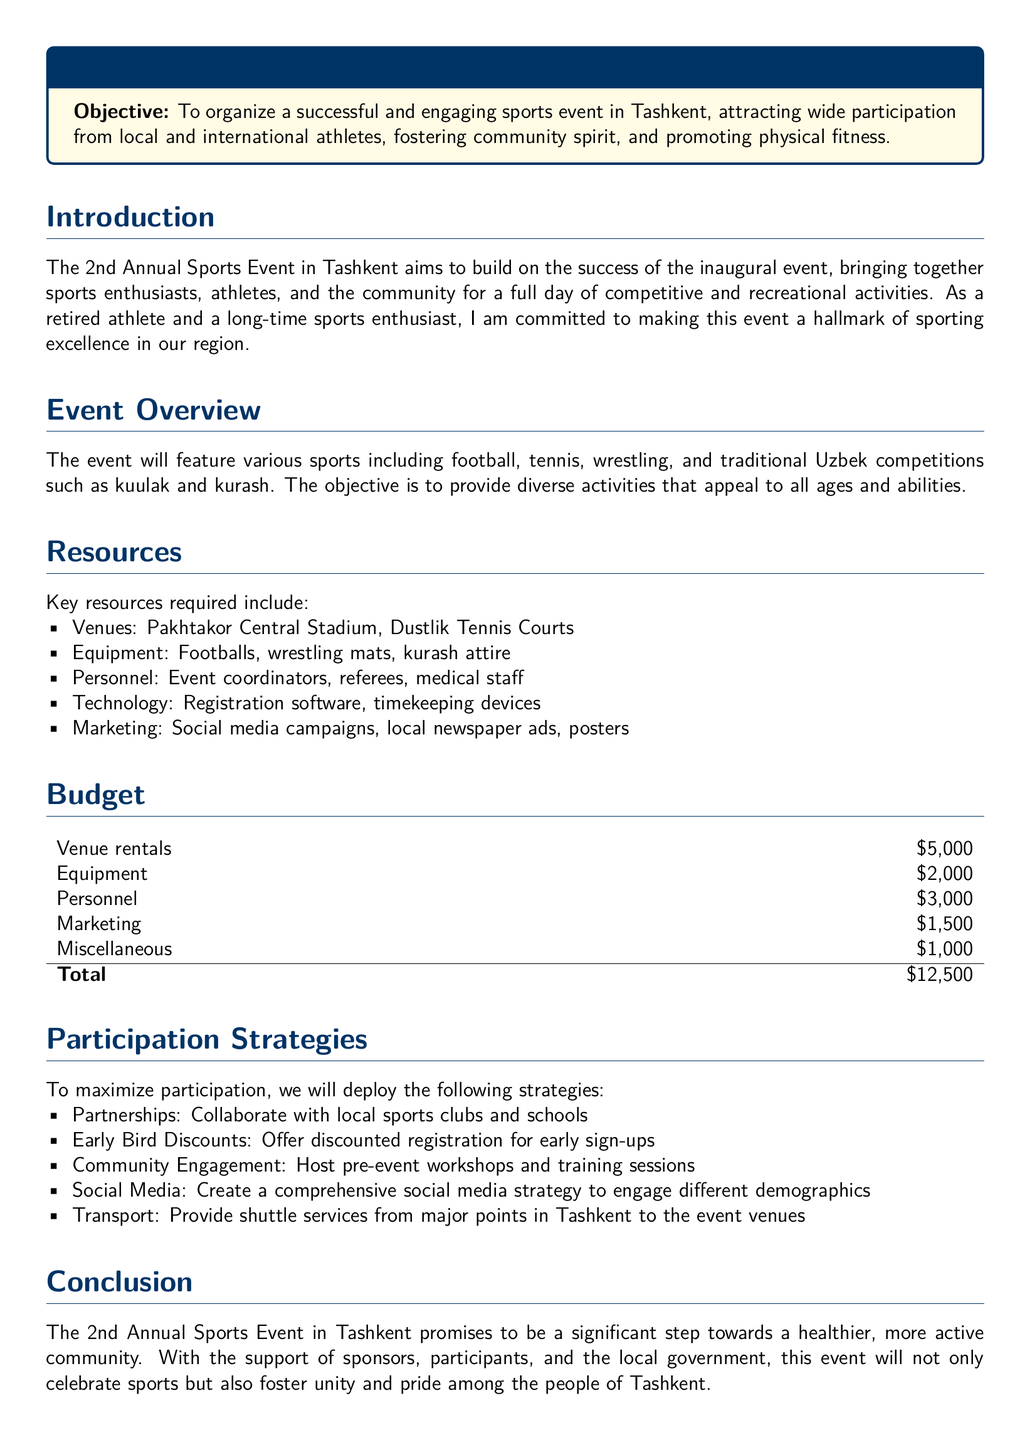What is the total budget for the event? The total budget is the sum of all cost items listed in the budget section, which is $5,000 + $2,000 + $3,000 + $1,500 + $1,000.
Answer: $12,500 What sports will be featured in the event? The document lists specific sports that will be part of the event, including football, tennis, wrestling, and traditional Uzbek competitions.
Answer: Football, tennis, wrestling, kuulak, kurash What is the name of the main venue for the event? The proposal specifies the primary venue being used for the event, which is a significant location for sports in Tashkent.
Answer: Pakhtakor Central Stadium What marketing strategies will be employed? The document enumerates various marketing strategies planned to promote the event, which include social media campaigns and newspaper ads.
Answer: Social media campaigns, local newspaper ads, posters Who is responsible for event coordination? This question explores the personnel needed for the event as stated in the resources section of the proposal.
Answer: Event coordinators What will be offered as an incentive for early registration? The proposal outlines a strategy to encourage quicker sign-ups by providing a specific type of deal or offer for those who register early.
Answer: Early Bird Discounts What type of workshops will be hosted before the event? The proposal mentions community engagement activities planned leading up to the event, which include specific types of informative and training activities.
Answer: Pre-event workshops and training sessions What is the purpose of the Annual Sports Event? The document outlines the overall objectives of the event, emphasizing involvement in the community and promoting physical fitness.
Answer: To organize a successful and engaging sports event in Tashkent How many personnel costs are projected in the budget? This question targets a specific cost detail found in the budget section concerning the expenses related to staffing for the event.
Answer: $3,000 